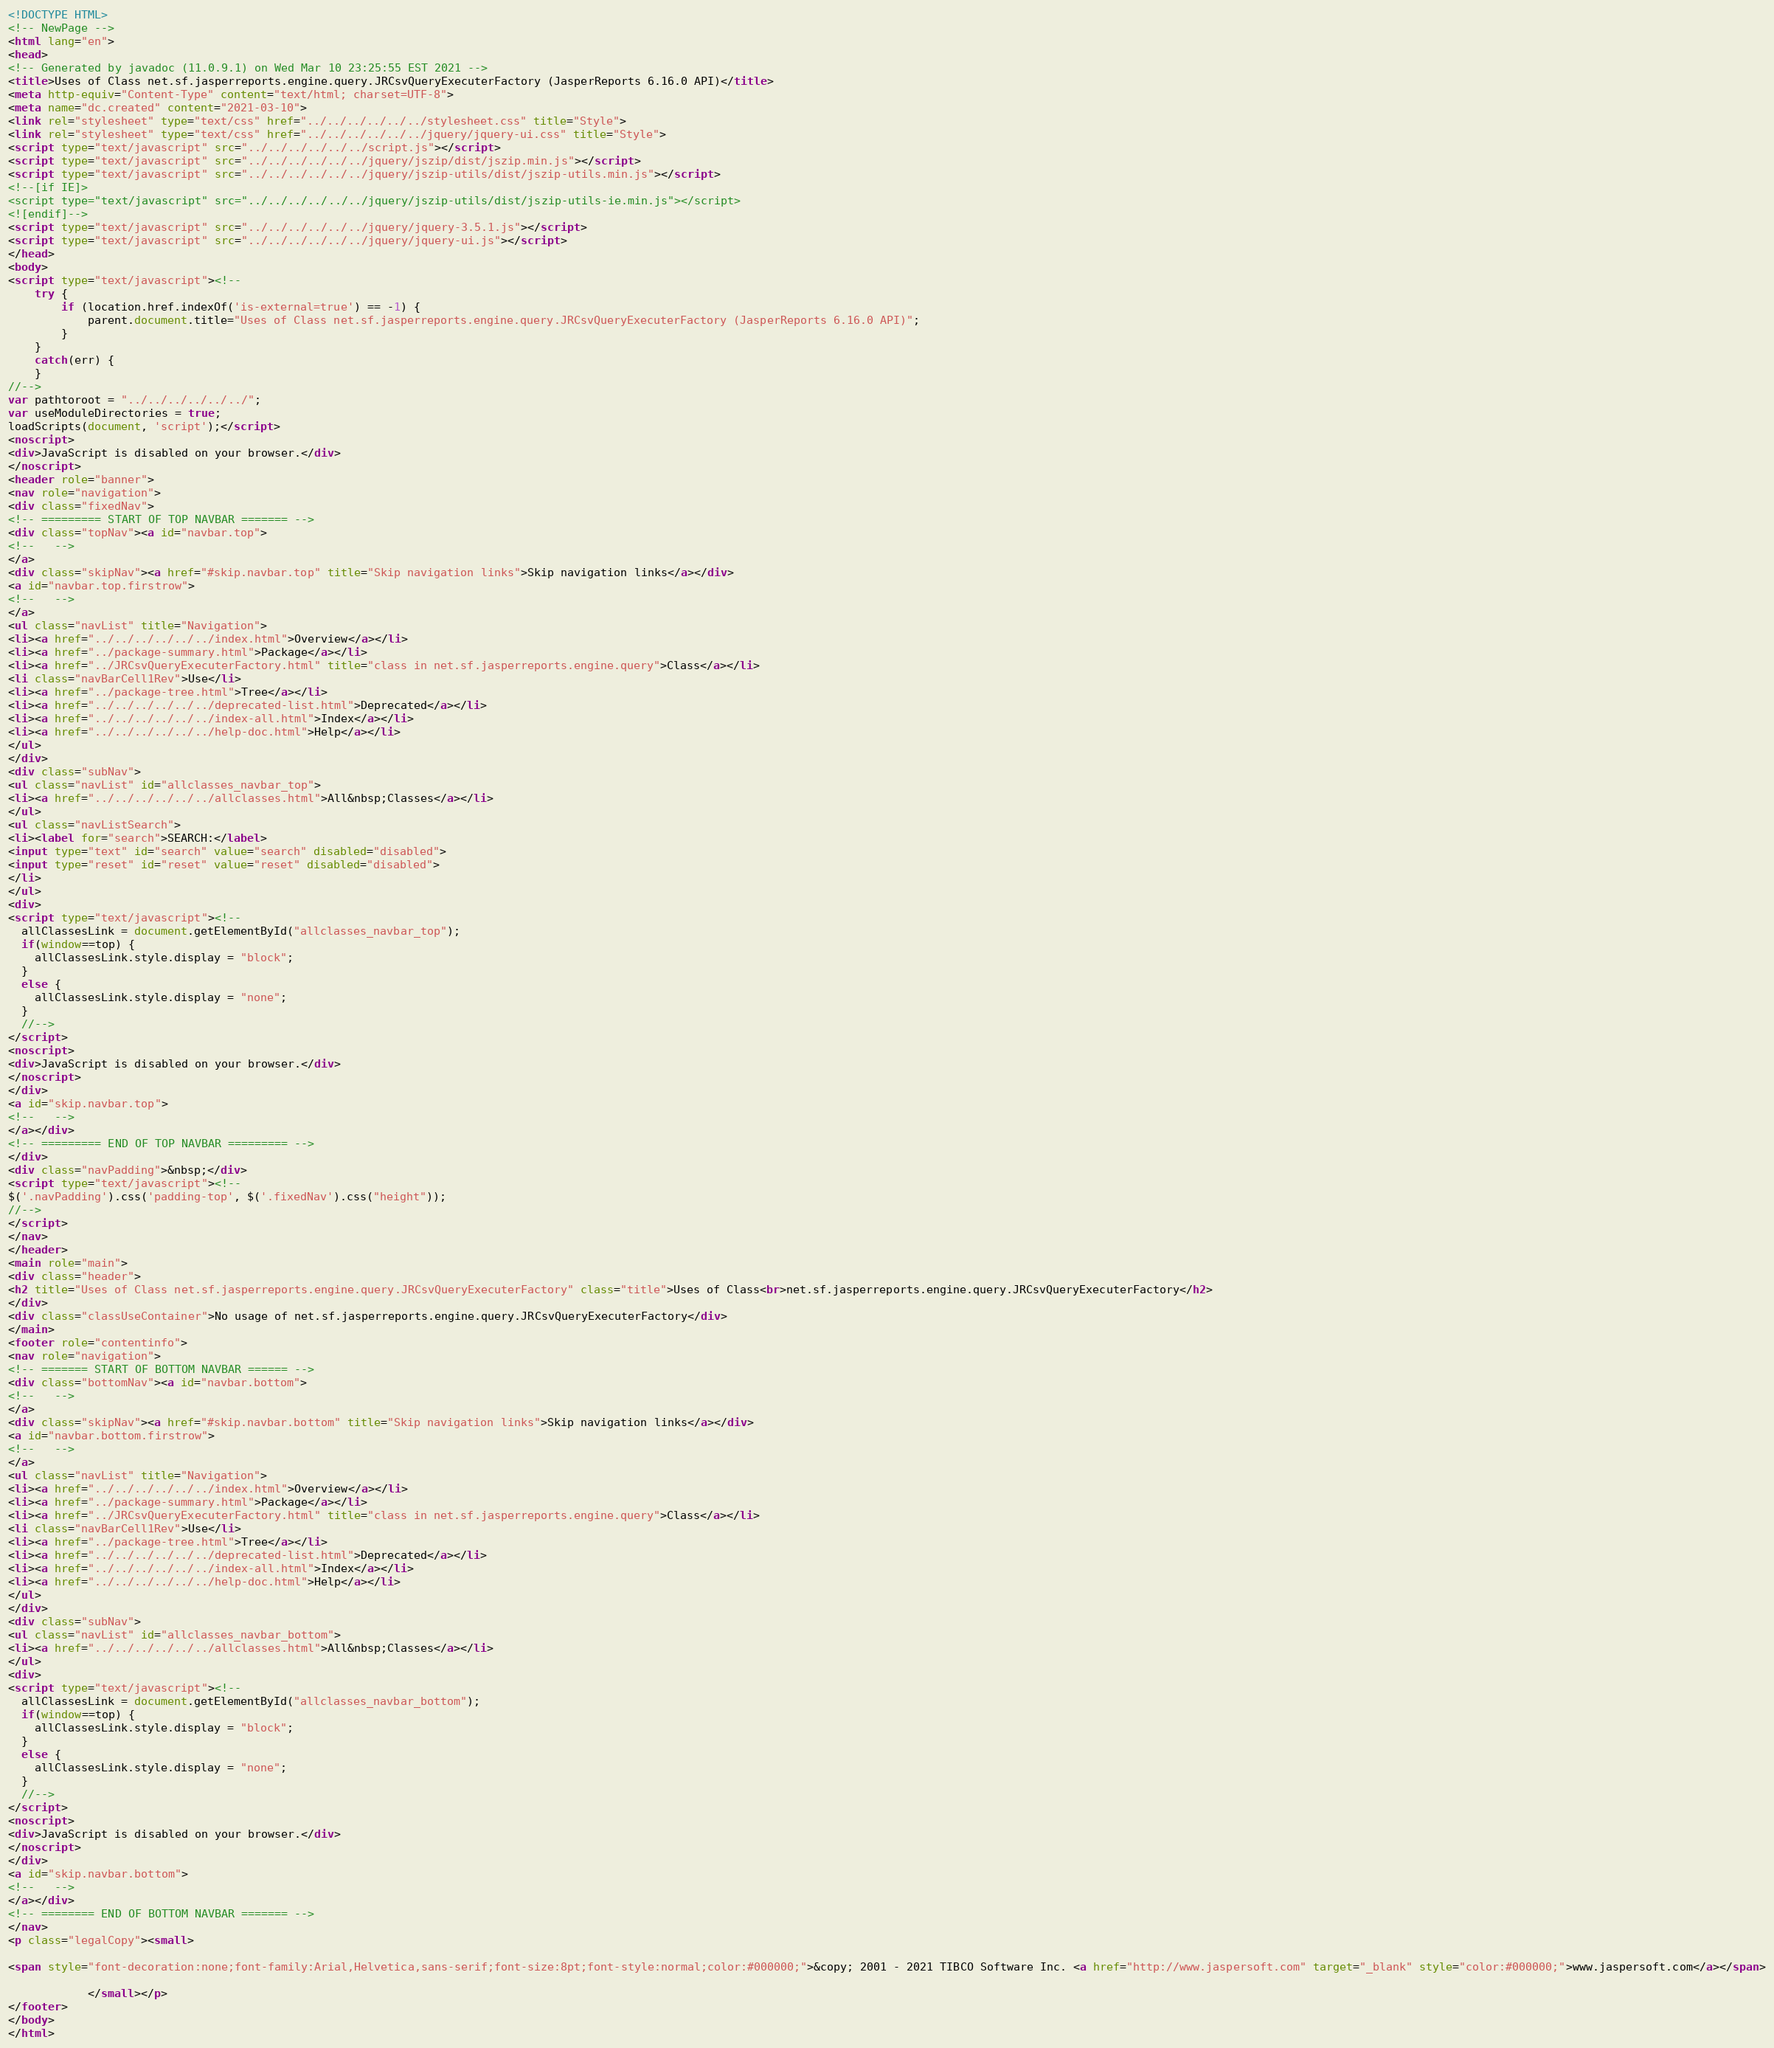Convert code to text. <code><loc_0><loc_0><loc_500><loc_500><_HTML_><!DOCTYPE HTML>
<!-- NewPage -->
<html lang="en">
<head>
<!-- Generated by javadoc (11.0.9.1) on Wed Mar 10 23:25:55 EST 2021 -->
<title>Uses of Class net.sf.jasperreports.engine.query.JRCsvQueryExecuterFactory (JasperReports 6.16.0 API)</title>
<meta http-equiv="Content-Type" content="text/html; charset=UTF-8">
<meta name="dc.created" content="2021-03-10">
<link rel="stylesheet" type="text/css" href="../../../../../../stylesheet.css" title="Style">
<link rel="stylesheet" type="text/css" href="../../../../../../jquery/jquery-ui.css" title="Style">
<script type="text/javascript" src="../../../../../../script.js"></script>
<script type="text/javascript" src="../../../../../../jquery/jszip/dist/jszip.min.js"></script>
<script type="text/javascript" src="../../../../../../jquery/jszip-utils/dist/jszip-utils.min.js"></script>
<!--[if IE]>
<script type="text/javascript" src="../../../../../../jquery/jszip-utils/dist/jszip-utils-ie.min.js"></script>
<![endif]-->
<script type="text/javascript" src="../../../../../../jquery/jquery-3.5.1.js"></script>
<script type="text/javascript" src="../../../../../../jquery/jquery-ui.js"></script>
</head>
<body>
<script type="text/javascript"><!--
    try {
        if (location.href.indexOf('is-external=true') == -1) {
            parent.document.title="Uses of Class net.sf.jasperreports.engine.query.JRCsvQueryExecuterFactory (JasperReports 6.16.0 API)";
        }
    }
    catch(err) {
    }
//-->
var pathtoroot = "../../../../../../";
var useModuleDirectories = true;
loadScripts(document, 'script');</script>
<noscript>
<div>JavaScript is disabled on your browser.</div>
</noscript>
<header role="banner">
<nav role="navigation">
<div class="fixedNav">
<!-- ========= START OF TOP NAVBAR ======= -->
<div class="topNav"><a id="navbar.top">
<!--   -->
</a>
<div class="skipNav"><a href="#skip.navbar.top" title="Skip navigation links">Skip navigation links</a></div>
<a id="navbar.top.firstrow">
<!--   -->
</a>
<ul class="navList" title="Navigation">
<li><a href="../../../../../../index.html">Overview</a></li>
<li><a href="../package-summary.html">Package</a></li>
<li><a href="../JRCsvQueryExecuterFactory.html" title="class in net.sf.jasperreports.engine.query">Class</a></li>
<li class="navBarCell1Rev">Use</li>
<li><a href="../package-tree.html">Tree</a></li>
<li><a href="../../../../../../deprecated-list.html">Deprecated</a></li>
<li><a href="../../../../../../index-all.html">Index</a></li>
<li><a href="../../../../../../help-doc.html">Help</a></li>
</ul>
</div>
<div class="subNav">
<ul class="navList" id="allclasses_navbar_top">
<li><a href="../../../../../../allclasses.html">All&nbsp;Classes</a></li>
</ul>
<ul class="navListSearch">
<li><label for="search">SEARCH:</label>
<input type="text" id="search" value="search" disabled="disabled">
<input type="reset" id="reset" value="reset" disabled="disabled">
</li>
</ul>
<div>
<script type="text/javascript"><!--
  allClassesLink = document.getElementById("allclasses_navbar_top");
  if(window==top) {
    allClassesLink.style.display = "block";
  }
  else {
    allClassesLink.style.display = "none";
  }
  //-->
</script>
<noscript>
<div>JavaScript is disabled on your browser.</div>
</noscript>
</div>
<a id="skip.navbar.top">
<!--   -->
</a></div>
<!-- ========= END OF TOP NAVBAR ========= -->
</div>
<div class="navPadding">&nbsp;</div>
<script type="text/javascript"><!--
$('.navPadding').css('padding-top', $('.fixedNav').css("height"));
//-->
</script>
</nav>
</header>
<main role="main">
<div class="header">
<h2 title="Uses of Class net.sf.jasperreports.engine.query.JRCsvQueryExecuterFactory" class="title">Uses of Class<br>net.sf.jasperreports.engine.query.JRCsvQueryExecuterFactory</h2>
</div>
<div class="classUseContainer">No usage of net.sf.jasperreports.engine.query.JRCsvQueryExecuterFactory</div>
</main>
<footer role="contentinfo">
<nav role="navigation">
<!-- ======= START OF BOTTOM NAVBAR ====== -->
<div class="bottomNav"><a id="navbar.bottom">
<!--   -->
</a>
<div class="skipNav"><a href="#skip.navbar.bottom" title="Skip navigation links">Skip navigation links</a></div>
<a id="navbar.bottom.firstrow">
<!--   -->
</a>
<ul class="navList" title="Navigation">
<li><a href="../../../../../../index.html">Overview</a></li>
<li><a href="../package-summary.html">Package</a></li>
<li><a href="../JRCsvQueryExecuterFactory.html" title="class in net.sf.jasperreports.engine.query">Class</a></li>
<li class="navBarCell1Rev">Use</li>
<li><a href="../package-tree.html">Tree</a></li>
<li><a href="../../../../../../deprecated-list.html">Deprecated</a></li>
<li><a href="../../../../../../index-all.html">Index</a></li>
<li><a href="../../../../../../help-doc.html">Help</a></li>
</ul>
</div>
<div class="subNav">
<ul class="navList" id="allclasses_navbar_bottom">
<li><a href="../../../../../../allclasses.html">All&nbsp;Classes</a></li>
</ul>
<div>
<script type="text/javascript"><!--
  allClassesLink = document.getElementById("allclasses_navbar_bottom");
  if(window==top) {
    allClassesLink.style.display = "block";
  }
  else {
    allClassesLink.style.display = "none";
  }
  //-->
</script>
<noscript>
<div>JavaScript is disabled on your browser.</div>
</noscript>
</div>
<a id="skip.navbar.bottom">
<!--   -->
</a></div>
<!-- ======== END OF BOTTOM NAVBAR ======= -->
</nav>
<p class="legalCopy"><small>

<span style="font-decoration:none;font-family:Arial,Helvetica,sans-serif;font-size:8pt;font-style:normal;color:#000000;">&copy; 2001 - 2021 TIBCO Software Inc. <a href="http://www.jaspersoft.com" target="_blank" style="color:#000000;">www.jaspersoft.com</a></span>

			</small></p>
</footer>
</body>
</html>
</code> 